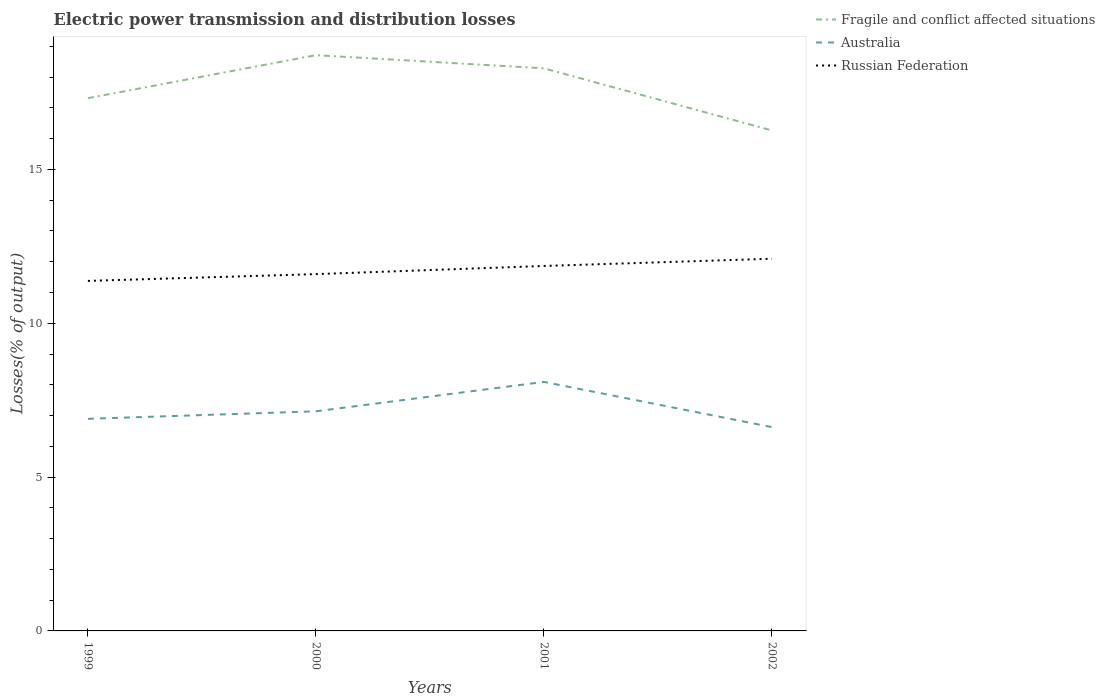Does the line corresponding to Russian Federation intersect with the line corresponding to Fragile and conflict affected situations?
Your answer should be very brief. No. Across all years, what is the maximum electric power transmission and distribution losses in Fragile and conflict affected situations?
Your answer should be very brief. 16.27. In which year was the electric power transmission and distribution losses in Russian Federation maximum?
Provide a succinct answer. 1999. What is the total electric power transmission and distribution losses in Russian Federation in the graph?
Make the answer very short. -0.23. What is the difference between the highest and the second highest electric power transmission and distribution losses in Australia?
Give a very brief answer. 1.47. How many years are there in the graph?
Offer a terse response. 4. How are the legend labels stacked?
Make the answer very short. Vertical. What is the title of the graph?
Keep it short and to the point. Electric power transmission and distribution losses. Does "Zambia" appear as one of the legend labels in the graph?
Provide a short and direct response. No. What is the label or title of the Y-axis?
Give a very brief answer. Losses(% of output). What is the Losses(% of output) of Fragile and conflict affected situations in 1999?
Provide a short and direct response. 17.32. What is the Losses(% of output) of Australia in 1999?
Your answer should be very brief. 6.89. What is the Losses(% of output) of Russian Federation in 1999?
Offer a terse response. 11.38. What is the Losses(% of output) in Fragile and conflict affected situations in 2000?
Provide a short and direct response. 18.71. What is the Losses(% of output) in Australia in 2000?
Your response must be concise. 7.14. What is the Losses(% of output) in Russian Federation in 2000?
Offer a very short reply. 11.6. What is the Losses(% of output) of Fragile and conflict affected situations in 2001?
Your answer should be very brief. 18.29. What is the Losses(% of output) of Australia in 2001?
Provide a succinct answer. 8.09. What is the Losses(% of output) in Russian Federation in 2001?
Offer a terse response. 11.86. What is the Losses(% of output) in Fragile and conflict affected situations in 2002?
Keep it short and to the point. 16.27. What is the Losses(% of output) in Australia in 2002?
Provide a short and direct response. 6.62. What is the Losses(% of output) of Russian Federation in 2002?
Your answer should be very brief. 12.1. Across all years, what is the maximum Losses(% of output) of Fragile and conflict affected situations?
Your answer should be very brief. 18.71. Across all years, what is the maximum Losses(% of output) in Australia?
Keep it short and to the point. 8.09. Across all years, what is the maximum Losses(% of output) in Russian Federation?
Provide a succinct answer. 12.1. Across all years, what is the minimum Losses(% of output) in Fragile and conflict affected situations?
Ensure brevity in your answer.  16.27. Across all years, what is the minimum Losses(% of output) in Australia?
Give a very brief answer. 6.62. Across all years, what is the minimum Losses(% of output) in Russian Federation?
Your answer should be very brief. 11.38. What is the total Losses(% of output) in Fragile and conflict affected situations in the graph?
Ensure brevity in your answer.  70.58. What is the total Losses(% of output) of Australia in the graph?
Make the answer very short. 28.75. What is the total Losses(% of output) in Russian Federation in the graph?
Provide a short and direct response. 46.93. What is the difference between the Losses(% of output) of Fragile and conflict affected situations in 1999 and that in 2000?
Your response must be concise. -1.4. What is the difference between the Losses(% of output) in Australia in 1999 and that in 2000?
Offer a terse response. -0.24. What is the difference between the Losses(% of output) in Russian Federation in 1999 and that in 2000?
Offer a terse response. -0.22. What is the difference between the Losses(% of output) in Fragile and conflict affected situations in 1999 and that in 2001?
Your answer should be compact. -0.97. What is the difference between the Losses(% of output) in Australia in 1999 and that in 2001?
Offer a terse response. -1.2. What is the difference between the Losses(% of output) in Russian Federation in 1999 and that in 2001?
Provide a short and direct response. -0.49. What is the difference between the Losses(% of output) of Fragile and conflict affected situations in 1999 and that in 2002?
Keep it short and to the point. 1.05. What is the difference between the Losses(% of output) of Australia in 1999 and that in 2002?
Provide a short and direct response. 0.27. What is the difference between the Losses(% of output) in Russian Federation in 1999 and that in 2002?
Offer a very short reply. -0.72. What is the difference between the Losses(% of output) in Fragile and conflict affected situations in 2000 and that in 2001?
Make the answer very short. 0.43. What is the difference between the Losses(% of output) of Australia in 2000 and that in 2001?
Make the answer very short. -0.96. What is the difference between the Losses(% of output) in Russian Federation in 2000 and that in 2001?
Your response must be concise. -0.27. What is the difference between the Losses(% of output) of Fragile and conflict affected situations in 2000 and that in 2002?
Make the answer very short. 2.45. What is the difference between the Losses(% of output) of Australia in 2000 and that in 2002?
Your response must be concise. 0.51. What is the difference between the Losses(% of output) of Russian Federation in 2000 and that in 2002?
Your answer should be compact. -0.5. What is the difference between the Losses(% of output) in Fragile and conflict affected situations in 2001 and that in 2002?
Keep it short and to the point. 2.02. What is the difference between the Losses(% of output) in Australia in 2001 and that in 2002?
Give a very brief answer. 1.47. What is the difference between the Losses(% of output) in Russian Federation in 2001 and that in 2002?
Provide a short and direct response. -0.23. What is the difference between the Losses(% of output) in Fragile and conflict affected situations in 1999 and the Losses(% of output) in Australia in 2000?
Your answer should be very brief. 10.18. What is the difference between the Losses(% of output) of Fragile and conflict affected situations in 1999 and the Losses(% of output) of Russian Federation in 2000?
Your answer should be compact. 5.72. What is the difference between the Losses(% of output) in Australia in 1999 and the Losses(% of output) in Russian Federation in 2000?
Give a very brief answer. -4.7. What is the difference between the Losses(% of output) of Fragile and conflict affected situations in 1999 and the Losses(% of output) of Australia in 2001?
Provide a short and direct response. 9.22. What is the difference between the Losses(% of output) in Fragile and conflict affected situations in 1999 and the Losses(% of output) in Russian Federation in 2001?
Offer a very short reply. 5.45. What is the difference between the Losses(% of output) of Australia in 1999 and the Losses(% of output) of Russian Federation in 2001?
Offer a terse response. -4.97. What is the difference between the Losses(% of output) in Fragile and conflict affected situations in 1999 and the Losses(% of output) in Australia in 2002?
Provide a short and direct response. 10.69. What is the difference between the Losses(% of output) in Fragile and conflict affected situations in 1999 and the Losses(% of output) in Russian Federation in 2002?
Your answer should be very brief. 5.22. What is the difference between the Losses(% of output) of Australia in 1999 and the Losses(% of output) of Russian Federation in 2002?
Make the answer very short. -5.2. What is the difference between the Losses(% of output) in Fragile and conflict affected situations in 2000 and the Losses(% of output) in Australia in 2001?
Ensure brevity in your answer.  10.62. What is the difference between the Losses(% of output) of Fragile and conflict affected situations in 2000 and the Losses(% of output) of Russian Federation in 2001?
Ensure brevity in your answer.  6.85. What is the difference between the Losses(% of output) in Australia in 2000 and the Losses(% of output) in Russian Federation in 2001?
Your answer should be very brief. -4.72. What is the difference between the Losses(% of output) of Fragile and conflict affected situations in 2000 and the Losses(% of output) of Australia in 2002?
Offer a terse response. 12.09. What is the difference between the Losses(% of output) in Fragile and conflict affected situations in 2000 and the Losses(% of output) in Russian Federation in 2002?
Make the answer very short. 6.62. What is the difference between the Losses(% of output) in Australia in 2000 and the Losses(% of output) in Russian Federation in 2002?
Ensure brevity in your answer.  -4.96. What is the difference between the Losses(% of output) in Fragile and conflict affected situations in 2001 and the Losses(% of output) in Australia in 2002?
Your answer should be compact. 11.66. What is the difference between the Losses(% of output) of Fragile and conflict affected situations in 2001 and the Losses(% of output) of Russian Federation in 2002?
Offer a very short reply. 6.19. What is the difference between the Losses(% of output) of Australia in 2001 and the Losses(% of output) of Russian Federation in 2002?
Provide a succinct answer. -4. What is the average Losses(% of output) in Fragile and conflict affected situations per year?
Your answer should be compact. 17.65. What is the average Losses(% of output) of Australia per year?
Your answer should be compact. 7.19. What is the average Losses(% of output) of Russian Federation per year?
Provide a succinct answer. 11.73. In the year 1999, what is the difference between the Losses(% of output) of Fragile and conflict affected situations and Losses(% of output) of Australia?
Make the answer very short. 10.42. In the year 1999, what is the difference between the Losses(% of output) in Fragile and conflict affected situations and Losses(% of output) in Russian Federation?
Offer a terse response. 5.94. In the year 1999, what is the difference between the Losses(% of output) in Australia and Losses(% of output) in Russian Federation?
Make the answer very short. -4.48. In the year 2000, what is the difference between the Losses(% of output) of Fragile and conflict affected situations and Losses(% of output) of Australia?
Give a very brief answer. 11.57. In the year 2000, what is the difference between the Losses(% of output) in Fragile and conflict affected situations and Losses(% of output) in Russian Federation?
Provide a short and direct response. 7.12. In the year 2000, what is the difference between the Losses(% of output) in Australia and Losses(% of output) in Russian Federation?
Make the answer very short. -4.46. In the year 2001, what is the difference between the Losses(% of output) of Fragile and conflict affected situations and Losses(% of output) of Australia?
Your response must be concise. 10.19. In the year 2001, what is the difference between the Losses(% of output) of Fragile and conflict affected situations and Losses(% of output) of Russian Federation?
Your answer should be very brief. 6.42. In the year 2001, what is the difference between the Losses(% of output) of Australia and Losses(% of output) of Russian Federation?
Your answer should be very brief. -3.77. In the year 2002, what is the difference between the Losses(% of output) of Fragile and conflict affected situations and Losses(% of output) of Australia?
Ensure brevity in your answer.  9.64. In the year 2002, what is the difference between the Losses(% of output) of Fragile and conflict affected situations and Losses(% of output) of Russian Federation?
Offer a terse response. 4.17. In the year 2002, what is the difference between the Losses(% of output) of Australia and Losses(% of output) of Russian Federation?
Your response must be concise. -5.47. What is the ratio of the Losses(% of output) in Fragile and conflict affected situations in 1999 to that in 2000?
Provide a short and direct response. 0.93. What is the ratio of the Losses(% of output) of Australia in 1999 to that in 2000?
Your answer should be very brief. 0.97. What is the ratio of the Losses(% of output) of Fragile and conflict affected situations in 1999 to that in 2001?
Provide a short and direct response. 0.95. What is the ratio of the Losses(% of output) of Australia in 1999 to that in 2001?
Your response must be concise. 0.85. What is the ratio of the Losses(% of output) in Russian Federation in 1999 to that in 2001?
Your response must be concise. 0.96. What is the ratio of the Losses(% of output) in Fragile and conflict affected situations in 1999 to that in 2002?
Your answer should be compact. 1.06. What is the ratio of the Losses(% of output) in Australia in 1999 to that in 2002?
Give a very brief answer. 1.04. What is the ratio of the Losses(% of output) of Russian Federation in 1999 to that in 2002?
Your response must be concise. 0.94. What is the ratio of the Losses(% of output) in Fragile and conflict affected situations in 2000 to that in 2001?
Make the answer very short. 1.02. What is the ratio of the Losses(% of output) of Australia in 2000 to that in 2001?
Your answer should be compact. 0.88. What is the ratio of the Losses(% of output) of Russian Federation in 2000 to that in 2001?
Provide a succinct answer. 0.98. What is the ratio of the Losses(% of output) in Fragile and conflict affected situations in 2000 to that in 2002?
Provide a succinct answer. 1.15. What is the ratio of the Losses(% of output) in Australia in 2000 to that in 2002?
Your answer should be compact. 1.08. What is the ratio of the Losses(% of output) in Russian Federation in 2000 to that in 2002?
Keep it short and to the point. 0.96. What is the ratio of the Losses(% of output) of Fragile and conflict affected situations in 2001 to that in 2002?
Make the answer very short. 1.12. What is the ratio of the Losses(% of output) in Australia in 2001 to that in 2002?
Keep it short and to the point. 1.22. What is the ratio of the Losses(% of output) in Russian Federation in 2001 to that in 2002?
Your answer should be very brief. 0.98. What is the difference between the highest and the second highest Losses(% of output) in Fragile and conflict affected situations?
Keep it short and to the point. 0.43. What is the difference between the highest and the second highest Losses(% of output) of Australia?
Provide a succinct answer. 0.96. What is the difference between the highest and the second highest Losses(% of output) of Russian Federation?
Offer a terse response. 0.23. What is the difference between the highest and the lowest Losses(% of output) in Fragile and conflict affected situations?
Ensure brevity in your answer.  2.45. What is the difference between the highest and the lowest Losses(% of output) of Australia?
Offer a very short reply. 1.47. What is the difference between the highest and the lowest Losses(% of output) in Russian Federation?
Give a very brief answer. 0.72. 